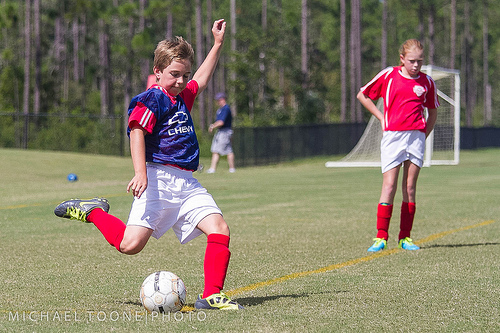<image>
Can you confirm if the player is on the football? No. The player is not positioned on the football. They may be near each other, but the player is not supported by or resting on top of the football. Is the boy in front of the ball? No. The boy is not in front of the ball. The spatial positioning shows a different relationship between these objects. Is the child in front of the ball? No. The child is not in front of the ball. The spatial positioning shows a different relationship between these objects. 